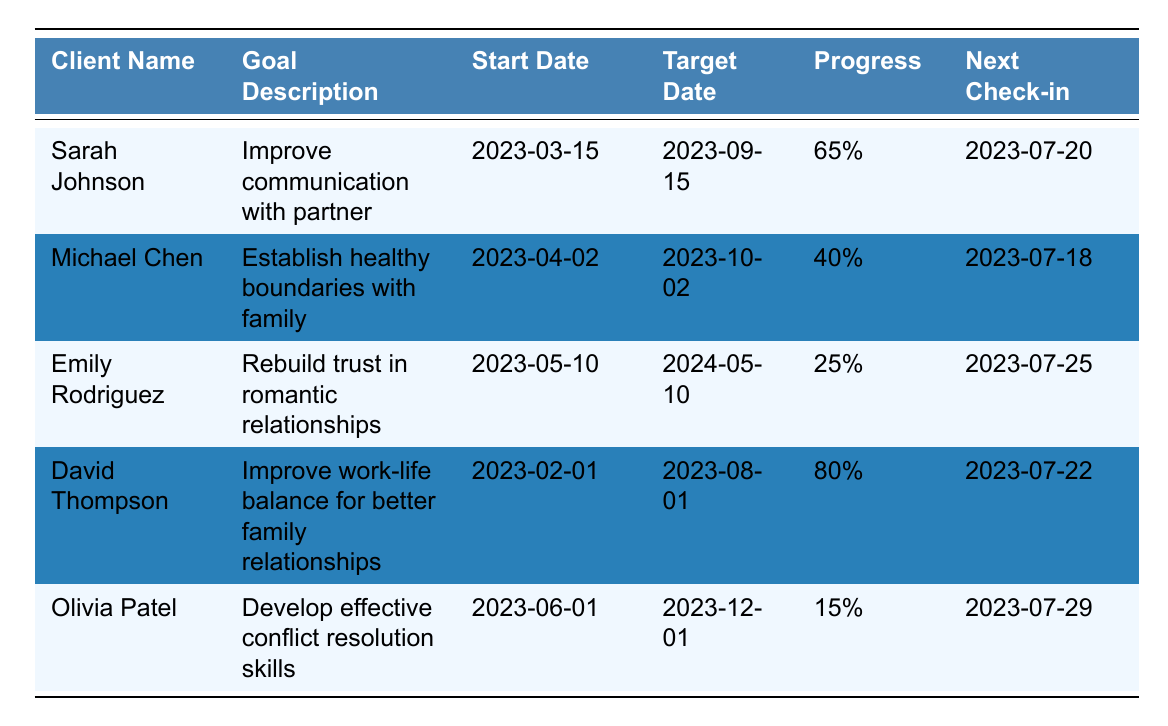What is the goal description for Sarah Johnson? Sarah Johnson's goal description can be found in the second column of her row. It states, "Improve communication with partner."
Answer: Improve communication with partner Which client has the highest progress percentage? By comparing the progress percentages, David Thompson has the highest at 80%.
Answer: David Thompson What are the key milestones for Michael Chen? The key milestones are listed in the data under Michael Chen’s entry: "Learn to say 'no' assertively," "Identify personal needs and values," and "Have open conversations with family members."
Answer: Learn to say 'no' assertively, Identify personal needs and values, Have open conversations with family members What is the average progress percentage of all clients? To find the average, sum the progress percentages: 65 + 40 + 25 + 80 + 15 = 225. Divide by the number of clients (5): 225 / 5 = 45.
Answer: 45% Is Emily Rodriguez's last check-in date after Sarah Johnson's last check-in date? Comparing the dates, Emily Rodriguez's last check-in is 2023-06-25, which is after Sarah Johnson's last check-in on 2023-06-20. Therefore, the statement is true.
Answer: Yes Who has a target date in the year 2024? Upon inspection, Emily Rodriguez's target date is 2024-05-10, which makes her the client with a target date in that year.
Answer: Emily Rodriguez Which client is closest to reaching their goal based on progress? David Thompson has a progress percentage of 80%, indicating he is closest to achieving his goal.
Answer: David Thompson What is the difference in progress percentage between David Thompson and Olivia Patel? To find the difference, subtract Olivia Patel's percentage (15%) from David Thompson's (80%): 80 - 15 = 65.
Answer: 65% What are the next check-in dates for clients with a progress percentage below 50%? Michael Chen has a next check-in on 2023-07-18 and Emily Rodriguez has 2023-07-25. This information indicates both clients fall under this category.
Answer: 2023-07-18 and 2023-07-25 Are there any clients whose main goal is focused on improving relationship skills? Sarah Johnson's goal focuses on improving communication with her partner, which is a relationship skill. Additionally, Olivia Patel’s goal focuses on conflict resolution skills. Both apply.
Answer: Yes 